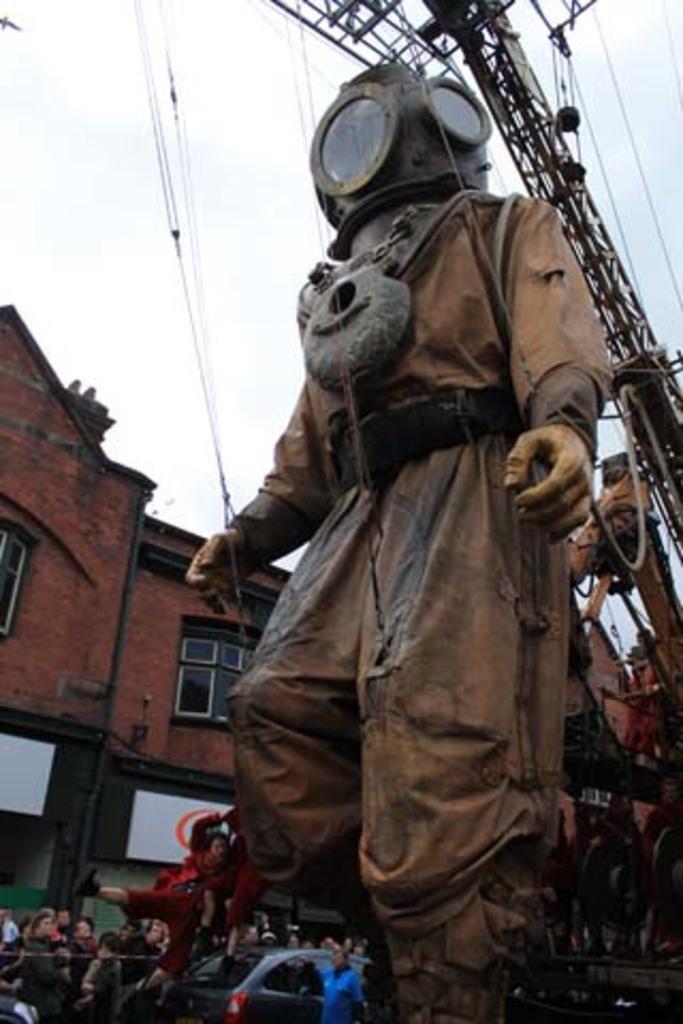In one or two sentences, can you explain what this image depicts? In this image we can see a few people, there is a statue, there is a house, windows, there is a vehicle, and wires, and a car, also we can see the sky. 